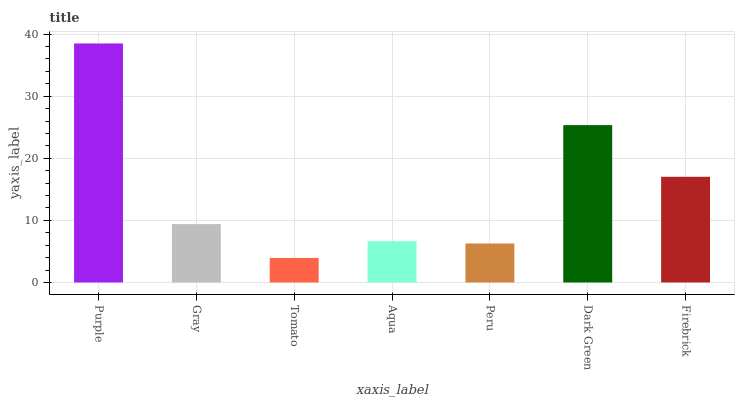Is Tomato the minimum?
Answer yes or no. Yes. Is Purple the maximum?
Answer yes or no. Yes. Is Gray the minimum?
Answer yes or no. No. Is Gray the maximum?
Answer yes or no. No. Is Purple greater than Gray?
Answer yes or no. Yes. Is Gray less than Purple?
Answer yes or no. Yes. Is Gray greater than Purple?
Answer yes or no. No. Is Purple less than Gray?
Answer yes or no. No. Is Gray the high median?
Answer yes or no. Yes. Is Gray the low median?
Answer yes or no. Yes. Is Firebrick the high median?
Answer yes or no. No. Is Dark Green the low median?
Answer yes or no. No. 